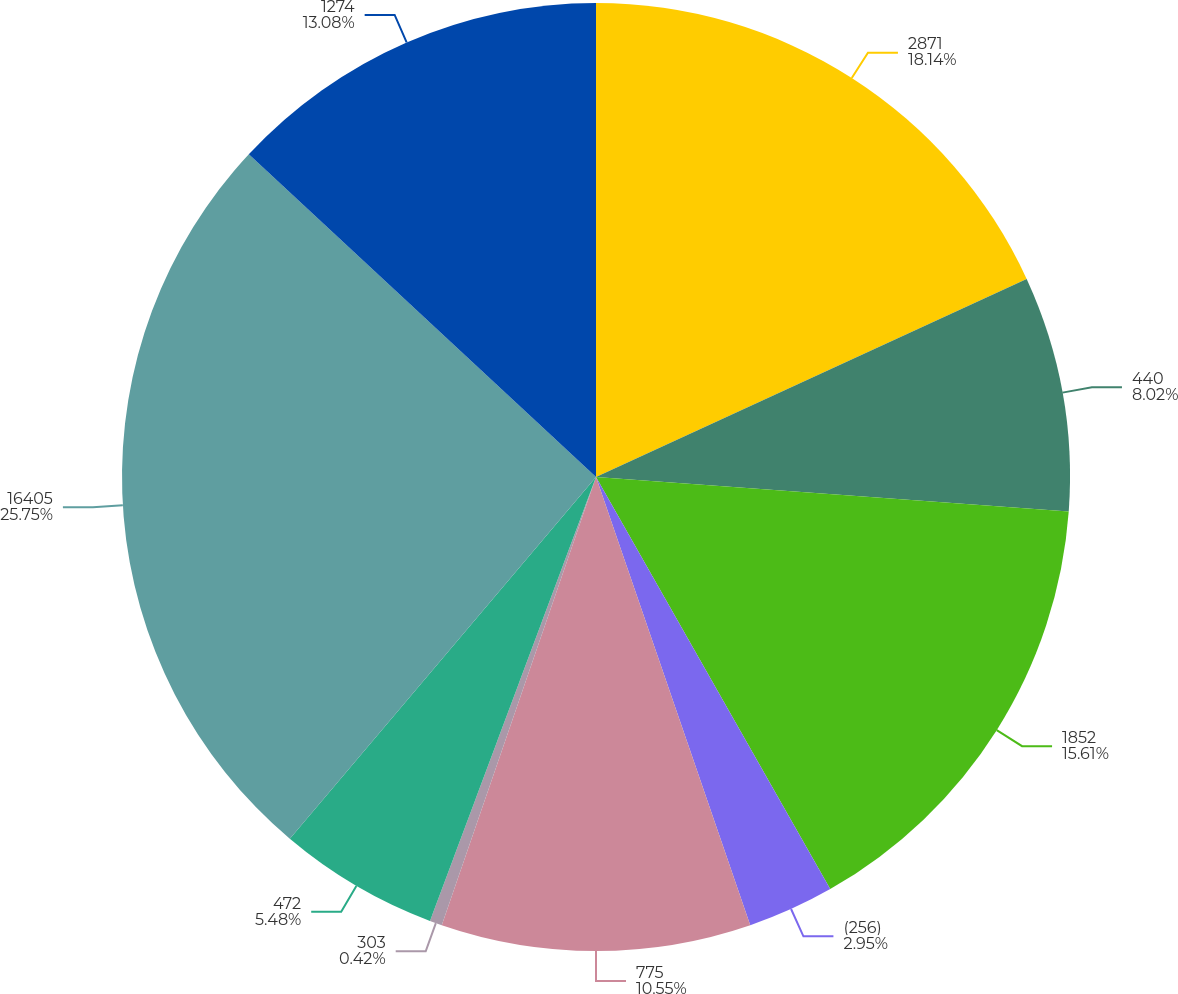Convert chart. <chart><loc_0><loc_0><loc_500><loc_500><pie_chart><fcel>2871<fcel>440<fcel>1852<fcel>(256)<fcel>775<fcel>303<fcel>472<fcel>16405<fcel>1274<nl><fcel>18.14%<fcel>8.02%<fcel>15.61%<fcel>2.95%<fcel>10.55%<fcel>0.42%<fcel>5.48%<fcel>25.74%<fcel>13.08%<nl></chart> 